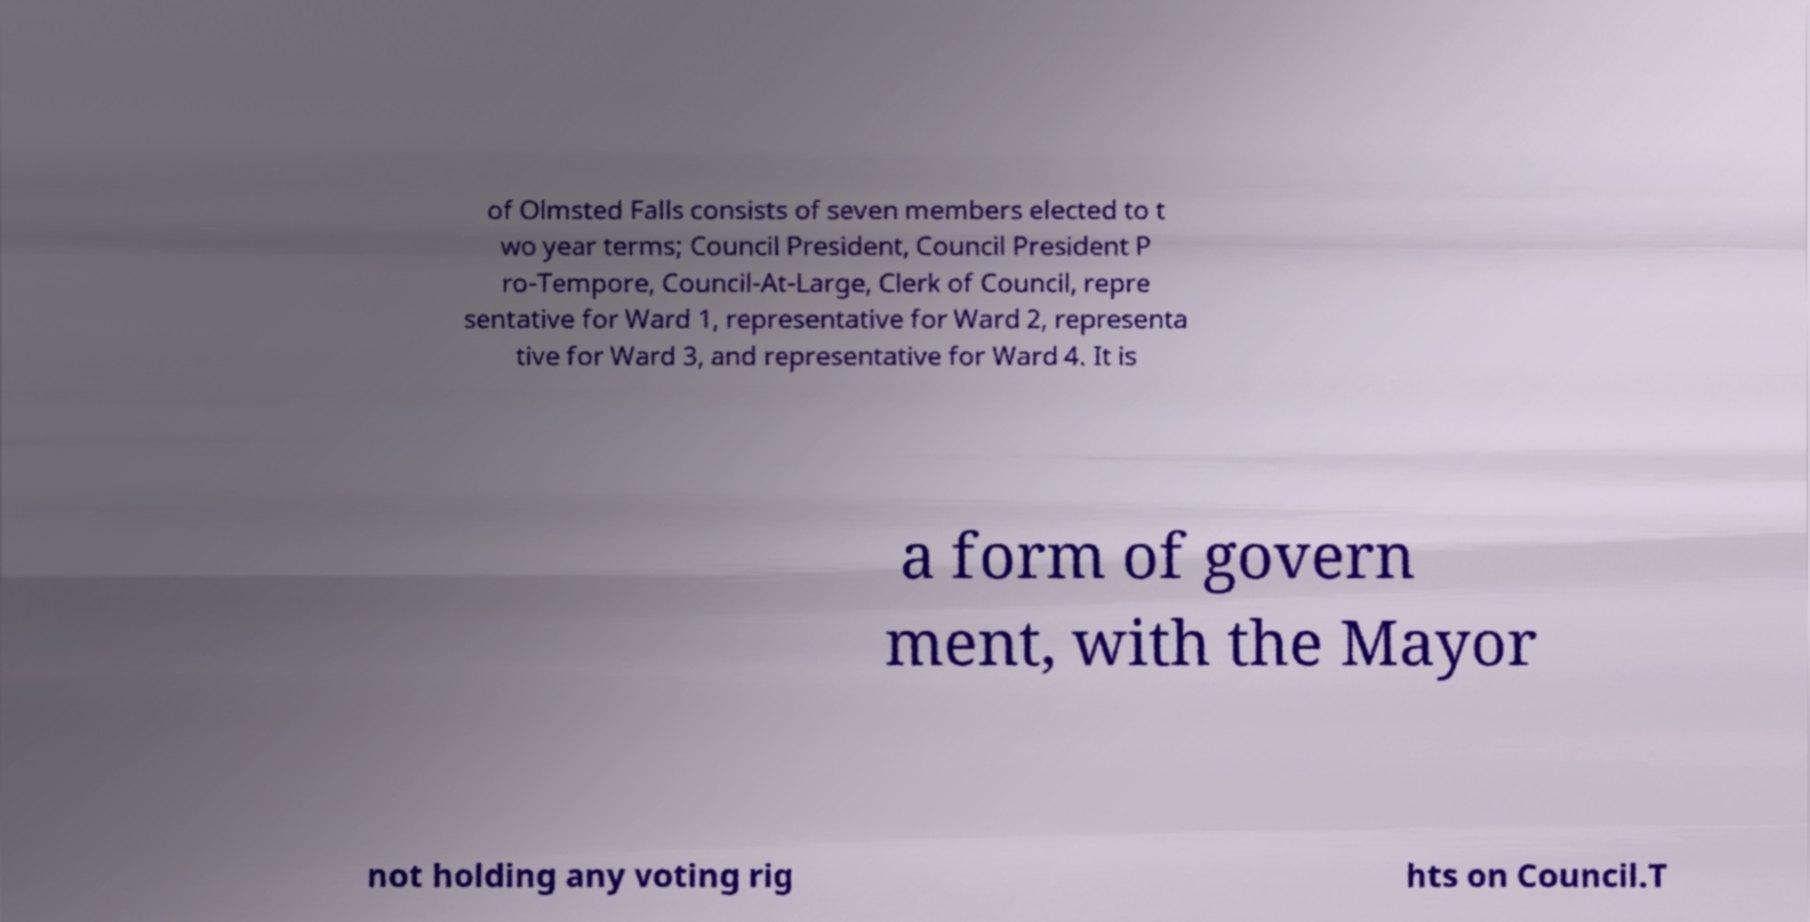There's text embedded in this image that I need extracted. Can you transcribe it verbatim? of Olmsted Falls consists of seven members elected to t wo year terms; Council President, Council President P ro-Tempore, Council-At-Large, Clerk of Council, repre sentative for Ward 1, representative for Ward 2, representa tive for Ward 3, and representative for Ward 4. It is a form of govern ment, with the Mayor not holding any voting rig hts on Council.T 